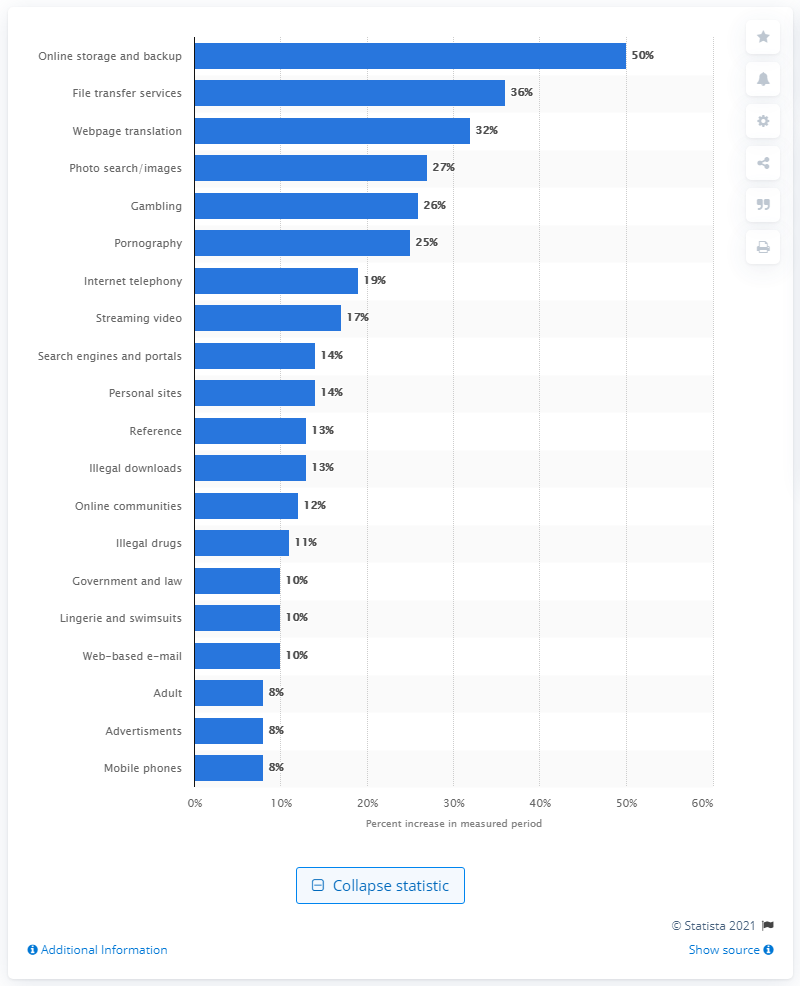Highlight a few significant elements in this photo. The amount of online storage and backup HTTPS traffic that increased from January to September 2015 was 50%. 